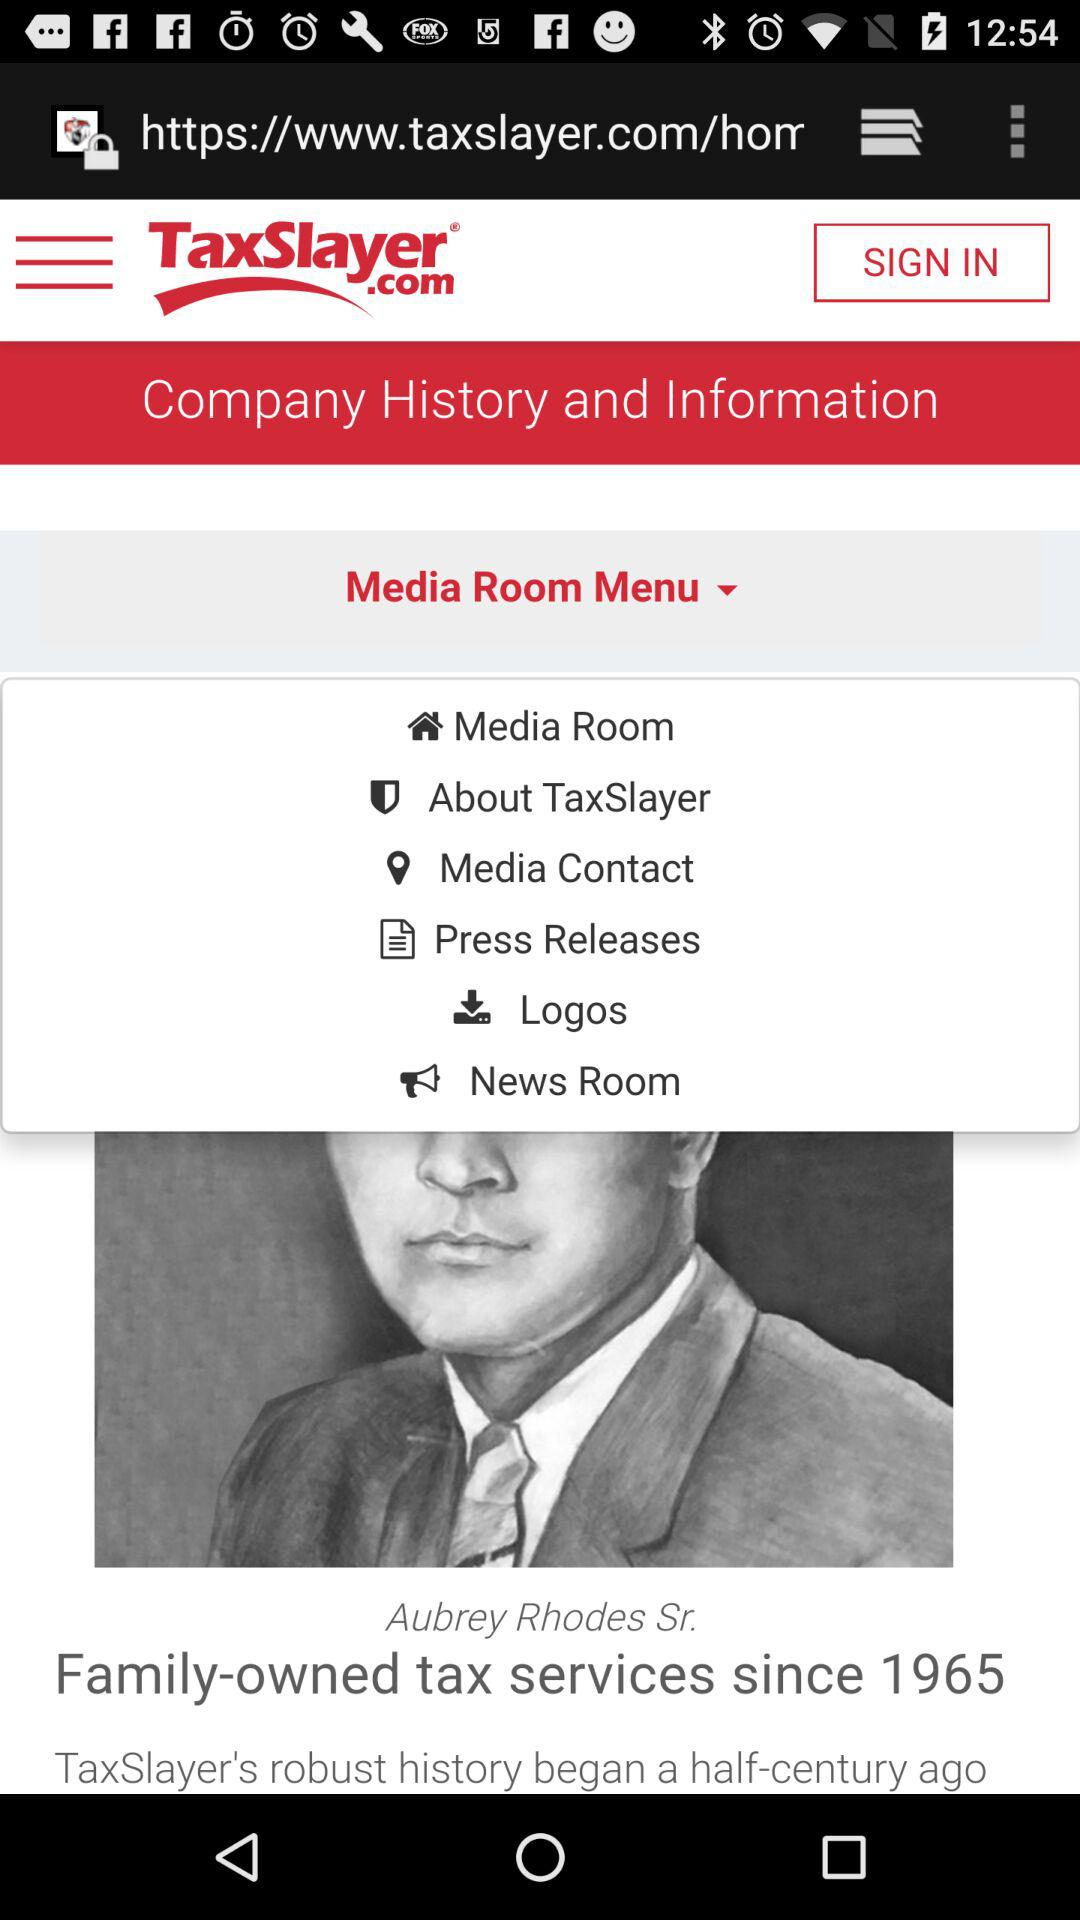Which option is currently selected under the menu drop-down list?
When the provided information is insufficient, respond with <no answer>. <no answer> 